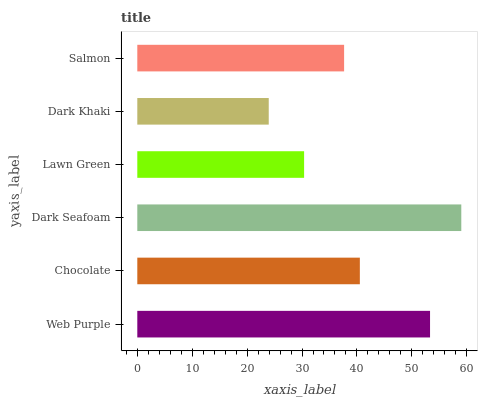Is Dark Khaki the minimum?
Answer yes or no. Yes. Is Dark Seafoam the maximum?
Answer yes or no. Yes. Is Chocolate the minimum?
Answer yes or no. No. Is Chocolate the maximum?
Answer yes or no. No. Is Web Purple greater than Chocolate?
Answer yes or no. Yes. Is Chocolate less than Web Purple?
Answer yes or no. Yes. Is Chocolate greater than Web Purple?
Answer yes or no. No. Is Web Purple less than Chocolate?
Answer yes or no. No. Is Chocolate the high median?
Answer yes or no. Yes. Is Salmon the low median?
Answer yes or no. Yes. Is Web Purple the high median?
Answer yes or no. No. Is Web Purple the low median?
Answer yes or no. No. 